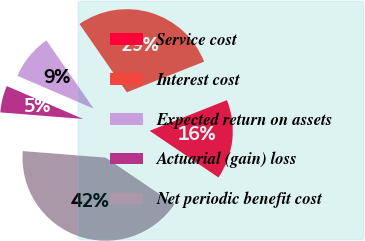Convert chart to OTSL. <chart><loc_0><loc_0><loc_500><loc_500><pie_chart><fcel>Service cost<fcel>Interest cost<fcel>Expected return on assets<fcel>Actuarial (gain) loss<fcel>Net periodic benefit cost<nl><fcel>15.5%<fcel>28.63%<fcel>8.88%<fcel>5.22%<fcel>41.77%<nl></chart> 